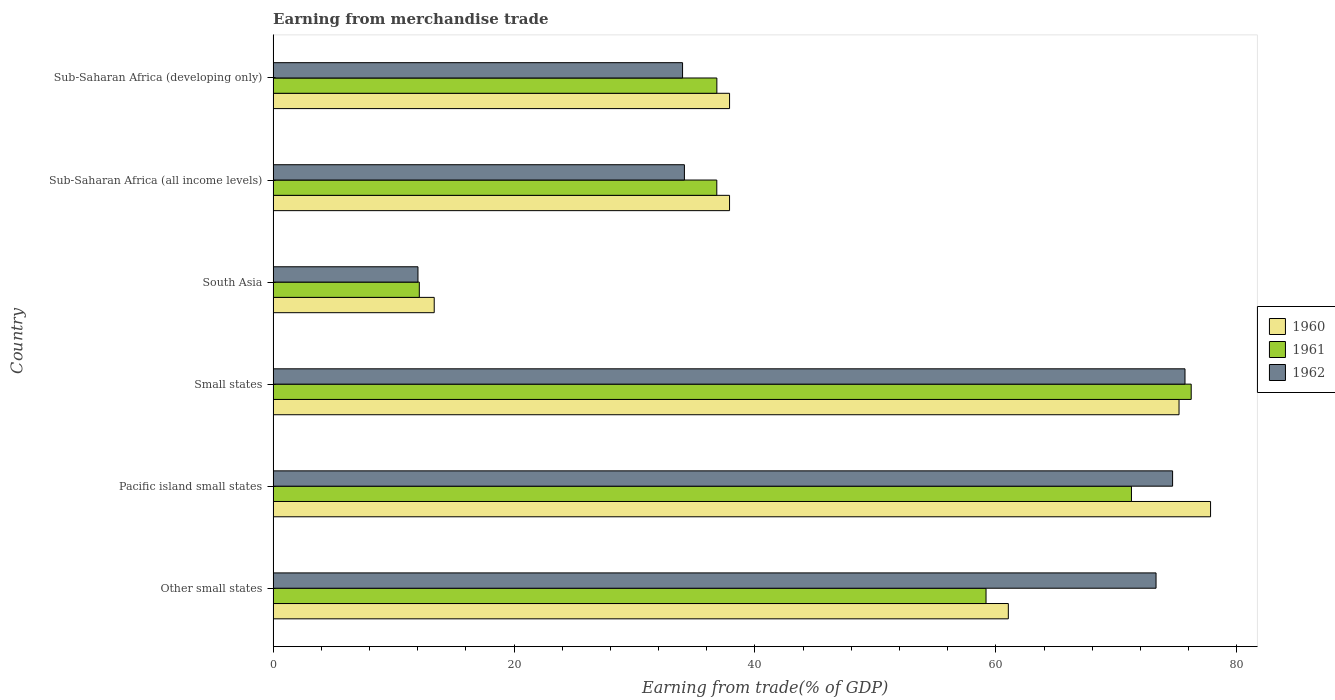How many groups of bars are there?
Offer a terse response. 6. What is the label of the 6th group of bars from the top?
Your response must be concise. Other small states. What is the earnings from trade in 1961 in South Asia?
Provide a short and direct response. 12.14. Across all countries, what is the maximum earnings from trade in 1961?
Your answer should be compact. 76.21. Across all countries, what is the minimum earnings from trade in 1962?
Offer a very short reply. 12.02. In which country was the earnings from trade in 1960 maximum?
Keep it short and to the point. Pacific island small states. What is the total earnings from trade in 1961 in the graph?
Give a very brief answer. 292.45. What is the difference between the earnings from trade in 1960 in Pacific island small states and that in Small states?
Make the answer very short. 2.62. What is the difference between the earnings from trade in 1962 in Other small states and the earnings from trade in 1960 in Small states?
Provide a short and direct response. -1.91. What is the average earnings from trade in 1960 per country?
Provide a short and direct response. 50.53. What is the difference between the earnings from trade in 1960 and earnings from trade in 1962 in Sub-Saharan Africa (developing only)?
Your response must be concise. 3.9. What is the ratio of the earnings from trade in 1961 in Small states to that in Sub-Saharan Africa (all income levels)?
Make the answer very short. 2.07. Is the difference between the earnings from trade in 1960 in Pacific island small states and Sub-Saharan Africa (all income levels) greater than the difference between the earnings from trade in 1962 in Pacific island small states and Sub-Saharan Africa (all income levels)?
Provide a succinct answer. No. What is the difference between the highest and the second highest earnings from trade in 1962?
Provide a short and direct response. 1.03. What is the difference between the highest and the lowest earnings from trade in 1962?
Provide a short and direct response. 63.67. What does the 1st bar from the top in Sub-Saharan Africa (all income levels) represents?
Your response must be concise. 1962. What does the 1st bar from the bottom in Other small states represents?
Your answer should be compact. 1960. What is the difference between two consecutive major ticks on the X-axis?
Make the answer very short. 20. Are the values on the major ticks of X-axis written in scientific E-notation?
Your answer should be very brief. No. Does the graph contain grids?
Ensure brevity in your answer.  No. What is the title of the graph?
Offer a very short reply. Earning from merchandise trade. What is the label or title of the X-axis?
Your answer should be compact. Earning from trade(% of GDP). What is the Earning from trade(% of GDP) of 1960 in Other small states?
Ensure brevity in your answer.  61.03. What is the Earning from trade(% of GDP) of 1961 in Other small states?
Your answer should be very brief. 59.18. What is the Earning from trade(% of GDP) in 1962 in Other small states?
Your answer should be very brief. 73.29. What is the Earning from trade(% of GDP) of 1960 in Pacific island small states?
Provide a short and direct response. 77.82. What is the Earning from trade(% of GDP) of 1961 in Pacific island small states?
Make the answer very short. 71.25. What is the Earning from trade(% of GDP) in 1962 in Pacific island small states?
Keep it short and to the point. 74.67. What is the Earning from trade(% of GDP) of 1960 in Small states?
Keep it short and to the point. 75.2. What is the Earning from trade(% of GDP) of 1961 in Small states?
Your answer should be compact. 76.21. What is the Earning from trade(% of GDP) in 1962 in Small states?
Make the answer very short. 75.7. What is the Earning from trade(% of GDP) of 1960 in South Asia?
Offer a terse response. 13.37. What is the Earning from trade(% of GDP) in 1961 in South Asia?
Offer a very short reply. 12.14. What is the Earning from trade(% of GDP) of 1962 in South Asia?
Offer a terse response. 12.02. What is the Earning from trade(% of GDP) of 1960 in Sub-Saharan Africa (all income levels)?
Make the answer very short. 37.89. What is the Earning from trade(% of GDP) in 1961 in Sub-Saharan Africa (all income levels)?
Provide a succinct answer. 36.83. What is the Earning from trade(% of GDP) in 1962 in Sub-Saharan Africa (all income levels)?
Your response must be concise. 34.14. What is the Earning from trade(% of GDP) in 1960 in Sub-Saharan Africa (developing only)?
Your answer should be very brief. 37.89. What is the Earning from trade(% of GDP) of 1961 in Sub-Saharan Africa (developing only)?
Your answer should be very brief. 36.84. What is the Earning from trade(% of GDP) of 1962 in Sub-Saharan Africa (developing only)?
Offer a very short reply. 33.99. Across all countries, what is the maximum Earning from trade(% of GDP) of 1960?
Give a very brief answer. 77.82. Across all countries, what is the maximum Earning from trade(% of GDP) in 1961?
Provide a succinct answer. 76.21. Across all countries, what is the maximum Earning from trade(% of GDP) of 1962?
Ensure brevity in your answer.  75.7. Across all countries, what is the minimum Earning from trade(% of GDP) in 1960?
Offer a terse response. 13.37. Across all countries, what is the minimum Earning from trade(% of GDP) of 1961?
Your response must be concise. 12.14. Across all countries, what is the minimum Earning from trade(% of GDP) of 1962?
Give a very brief answer. 12.02. What is the total Earning from trade(% of GDP) of 1960 in the graph?
Ensure brevity in your answer.  303.21. What is the total Earning from trade(% of GDP) in 1961 in the graph?
Provide a short and direct response. 292.45. What is the total Earning from trade(% of GDP) of 1962 in the graph?
Offer a terse response. 303.81. What is the difference between the Earning from trade(% of GDP) of 1960 in Other small states and that in Pacific island small states?
Offer a very short reply. -16.79. What is the difference between the Earning from trade(% of GDP) of 1961 in Other small states and that in Pacific island small states?
Your answer should be compact. -12.07. What is the difference between the Earning from trade(% of GDP) of 1962 in Other small states and that in Pacific island small states?
Offer a terse response. -1.37. What is the difference between the Earning from trade(% of GDP) in 1960 in Other small states and that in Small states?
Your response must be concise. -14.17. What is the difference between the Earning from trade(% of GDP) in 1961 in Other small states and that in Small states?
Offer a terse response. -17.03. What is the difference between the Earning from trade(% of GDP) in 1962 in Other small states and that in Small states?
Your answer should be compact. -2.4. What is the difference between the Earning from trade(% of GDP) of 1960 in Other small states and that in South Asia?
Ensure brevity in your answer.  47.66. What is the difference between the Earning from trade(% of GDP) of 1961 in Other small states and that in South Asia?
Offer a very short reply. 47.05. What is the difference between the Earning from trade(% of GDP) in 1962 in Other small states and that in South Asia?
Provide a succinct answer. 61.27. What is the difference between the Earning from trade(% of GDP) in 1960 in Other small states and that in Sub-Saharan Africa (all income levels)?
Your answer should be very brief. 23.14. What is the difference between the Earning from trade(% of GDP) of 1961 in Other small states and that in Sub-Saharan Africa (all income levels)?
Keep it short and to the point. 22.35. What is the difference between the Earning from trade(% of GDP) of 1962 in Other small states and that in Sub-Saharan Africa (all income levels)?
Give a very brief answer. 39.15. What is the difference between the Earning from trade(% of GDP) in 1960 in Other small states and that in Sub-Saharan Africa (developing only)?
Ensure brevity in your answer.  23.14. What is the difference between the Earning from trade(% of GDP) of 1961 in Other small states and that in Sub-Saharan Africa (developing only)?
Keep it short and to the point. 22.35. What is the difference between the Earning from trade(% of GDP) in 1962 in Other small states and that in Sub-Saharan Africa (developing only)?
Provide a short and direct response. 39.3. What is the difference between the Earning from trade(% of GDP) in 1960 in Pacific island small states and that in Small states?
Your answer should be compact. 2.62. What is the difference between the Earning from trade(% of GDP) in 1961 in Pacific island small states and that in Small states?
Your answer should be very brief. -4.96. What is the difference between the Earning from trade(% of GDP) in 1962 in Pacific island small states and that in Small states?
Keep it short and to the point. -1.03. What is the difference between the Earning from trade(% of GDP) of 1960 in Pacific island small states and that in South Asia?
Provide a short and direct response. 64.45. What is the difference between the Earning from trade(% of GDP) in 1961 in Pacific island small states and that in South Asia?
Give a very brief answer. 59.12. What is the difference between the Earning from trade(% of GDP) of 1962 in Pacific island small states and that in South Asia?
Your response must be concise. 62.64. What is the difference between the Earning from trade(% of GDP) of 1960 in Pacific island small states and that in Sub-Saharan Africa (all income levels)?
Give a very brief answer. 39.93. What is the difference between the Earning from trade(% of GDP) of 1961 in Pacific island small states and that in Sub-Saharan Africa (all income levels)?
Provide a succinct answer. 34.42. What is the difference between the Earning from trade(% of GDP) in 1962 in Pacific island small states and that in Sub-Saharan Africa (all income levels)?
Offer a terse response. 40.53. What is the difference between the Earning from trade(% of GDP) in 1960 in Pacific island small states and that in Sub-Saharan Africa (developing only)?
Offer a terse response. 39.93. What is the difference between the Earning from trade(% of GDP) of 1961 in Pacific island small states and that in Sub-Saharan Africa (developing only)?
Offer a terse response. 34.42. What is the difference between the Earning from trade(% of GDP) of 1962 in Pacific island small states and that in Sub-Saharan Africa (developing only)?
Provide a short and direct response. 40.68. What is the difference between the Earning from trade(% of GDP) in 1960 in Small states and that in South Asia?
Provide a succinct answer. 61.83. What is the difference between the Earning from trade(% of GDP) of 1961 in Small states and that in South Asia?
Keep it short and to the point. 64.08. What is the difference between the Earning from trade(% of GDP) in 1962 in Small states and that in South Asia?
Offer a very short reply. 63.67. What is the difference between the Earning from trade(% of GDP) of 1960 in Small states and that in Sub-Saharan Africa (all income levels)?
Keep it short and to the point. 37.31. What is the difference between the Earning from trade(% of GDP) in 1961 in Small states and that in Sub-Saharan Africa (all income levels)?
Provide a succinct answer. 39.38. What is the difference between the Earning from trade(% of GDP) of 1962 in Small states and that in Sub-Saharan Africa (all income levels)?
Give a very brief answer. 41.55. What is the difference between the Earning from trade(% of GDP) in 1960 in Small states and that in Sub-Saharan Africa (developing only)?
Give a very brief answer. 37.31. What is the difference between the Earning from trade(% of GDP) of 1961 in Small states and that in Sub-Saharan Africa (developing only)?
Provide a short and direct response. 39.38. What is the difference between the Earning from trade(% of GDP) of 1962 in Small states and that in Sub-Saharan Africa (developing only)?
Provide a short and direct response. 41.71. What is the difference between the Earning from trade(% of GDP) of 1960 in South Asia and that in Sub-Saharan Africa (all income levels)?
Your response must be concise. -24.52. What is the difference between the Earning from trade(% of GDP) of 1961 in South Asia and that in Sub-Saharan Africa (all income levels)?
Keep it short and to the point. -24.7. What is the difference between the Earning from trade(% of GDP) of 1962 in South Asia and that in Sub-Saharan Africa (all income levels)?
Offer a very short reply. -22.12. What is the difference between the Earning from trade(% of GDP) in 1960 in South Asia and that in Sub-Saharan Africa (developing only)?
Ensure brevity in your answer.  -24.52. What is the difference between the Earning from trade(% of GDP) in 1961 in South Asia and that in Sub-Saharan Africa (developing only)?
Give a very brief answer. -24.7. What is the difference between the Earning from trade(% of GDP) of 1962 in South Asia and that in Sub-Saharan Africa (developing only)?
Give a very brief answer. -21.96. What is the difference between the Earning from trade(% of GDP) of 1960 in Sub-Saharan Africa (all income levels) and that in Sub-Saharan Africa (developing only)?
Your answer should be compact. -0. What is the difference between the Earning from trade(% of GDP) of 1961 in Sub-Saharan Africa (all income levels) and that in Sub-Saharan Africa (developing only)?
Provide a short and direct response. -0. What is the difference between the Earning from trade(% of GDP) of 1962 in Sub-Saharan Africa (all income levels) and that in Sub-Saharan Africa (developing only)?
Make the answer very short. 0.15. What is the difference between the Earning from trade(% of GDP) of 1960 in Other small states and the Earning from trade(% of GDP) of 1961 in Pacific island small states?
Make the answer very short. -10.22. What is the difference between the Earning from trade(% of GDP) of 1960 in Other small states and the Earning from trade(% of GDP) of 1962 in Pacific island small states?
Offer a terse response. -13.64. What is the difference between the Earning from trade(% of GDP) in 1961 in Other small states and the Earning from trade(% of GDP) in 1962 in Pacific island small states?
Your response must be concise. -15.49. What is the difference between the Earning from trade(% of GDP) in 1960 in Other small states and the Earning from trade(% of GDP) in 1961 in Small states?
Offer a very short reply. -15.18. What is the difference between the Earning from trade(% of GDP) of 1960 in Other small states and the Earning from trade(% of GDP) of 1962 in Small states?
Provide a succinct answer. -14.67. What is the difference between the Earning from trade(% of GDP) in 1961 in Other small states and the Earning from trade(% of GDP) in 1962 in Small states?
Your response must be concise. -16.52. What is the difference between the Earning from trade(% of GDP) of 1960 in Other small states and the Earning from trade(% of GDP) of 1961 in South Asia?
Give a very brief answer. 48.9. What is the difference between the Earning from trade(% of GDP) of 1960 in Other small states and the Earning from trade(% of GDP) of 1962 in South Asia?
Keep it short and to the point. 49.01. What is the difference between the Earning from trade(% of GDP) of 1961 in Other small states and the Earning from trade(% of GDP) of 1962 in South Asia?
Ensure brevity in your answer.  47.16. What is the difference between the Earning from trade(% of GDP) of 1960 in Other small states and the Earning from trade(% of GDP) of 1961 in Sub-Saharan Africa (all income levels)?
Keep it short and to the point. 24.2. What is the difference between the Earning from trade(% of GDP) in 1960 in Other small states and the Earning from trade(% of GDP) in 1962 in Sub-Saharan Africa (all income levels)?
Ensure brevity in your answer.  26.89. What is the difference between the Earning from trade(% of GDP) of 1961 in Other small states and the Earning from trade(% of GDP) of 1962 in Sub-Saharan Africa (all income levels)?
Make the answer very short. 25.04. What is the difference between the Earning from trade(% of GDP) of 1960 in Other small states and the Earning from trade(% of GDP) of 1961 in Sub-Saharan Africa (developing only)?
Your response must be concise. 24.2. What is the difference between the Earning from trade(% of GDP) of 1960 in Other small states and the Earning from trade(% of GDP) of 1962 in Sub-Saharan Africa (developing only)?
Your answer should be very brief. 27.04. What is the difference between the Earning from trade(% of GDP) of 1961 in Other small states and the Earning from trade(% of GDP) of 1962 in Sub-Saharan Africa (developing only)?
Your answer should be compact. 25.19. What is the difference between the Earning from trade(% of GDP) in 1960 in Pacific island small states and the Earning from trade(% of GDP) in 1961 in Small states?
Keep it short and to the point. 1.61. What is the difference between the Earning from trade(% of GDP) of 1960 in Pacific island small states and the Earning from trade(% of GDP) of 1962 in Small states?
Your answer should be compact. 2.12. What is the difference between the Earning from trade(% of GDP) of 1961 in Pacific island small states and the Earning from trade(% of GDP) of 1962 in Small states?
Your answer should be compact. -4.44. What is the difference between the Earning from trade(% of GDP) of 1960 in Pacific island small states and the Earning from trade(% of GDP) of 1961 in South Asia?
Make the answer very short. 65.68. What is the difference between the Earning from trade(% of GDP) of 1960 in Pacific island small states and the Earning from trade(% of GDP) of 1962 in South Asia?
Offer a terse response. 65.8. What is the difference between the Earning from trade(% of GDP) of 1961 in Pacific island small states and the Earning from trade(% of GDP) of 1962 in South Asia?
Offer a terse response. 59.23. What is the difference between the Earning from trade(% of GDP) in 1960 in Pacific island small states and the Earning from trade(% of GDP) in 1961 in Sub-Saharan Africa (all income levels)?
Your response must be concise. 40.99. What is the difference between the Earning from trade(% of GDP) in 1960 in Pacific island small states and the Earning from trade(% of GDP) in 1962 in Sub-Saharan Africa (all income levels)?
Give a very brief answer. 43.68. What is the difference between the Earning from trade(% of GDP) of 1961 in Pacific island small states and the Earning from trade(% of GDP) of 1962 in Sub-Saharan Africa (all income levels)?
Offer a terse response. 37.11. What is the difference between the Earning from trade(% of GDP) of 1960 in Pacific island small states and the Earning from trade(% of GDP) of 1961 in Sub-Saharan Africa (developing only)?
Offer a very short reply. 40.98. What is the difference between the Earning from trade(% of GDP) of 1960 in Pacific island small states and the Earning from trade(% of GDP) of 1962 in Sub-Saharan Africa (developing only)?
Your response must be concise. 43.83. What is the difference between the Earning from trade(% of GDP) in 1961 in Pacific island small states and the Earning from trade(% of GDP) in 1962 in Sub-Saharan Africa (developing only)?
Your answer should be very brief. 37.26. What is the difference between the Earning from trade(% of GDP) of 1960 in Small states and the Earning from trade(% of GDP) of 1961 in South Asia?
Ensure brevity in your answer.  63.07. What is the difference between the Earning from trade(% of GDP) in 1960 in Small states and the Earning from trade(% of GDP) in 1962 in South Asia?
Your answer should be compact. 63.18. What is the difference between the Earning from trade(% of GDP) in 1961 in Small states and the Earning from trade(% of GDP) in 1962 in South Asia?
Your answer should be very brief. 64.19. What is the difference between the Earning from trade(% of GDP) of 1960 in Small states and the Earning from trade(% of GDP) of 1961 in Sub-Saharan Africa (all income levels)?
Give a very brief answer. 38.37. What is the difference between the Earning from trade(% of GDP) of 1960 in Small states and the Earning from trade(% of GDP) of 1962 in Sub-Saharan Africa (all income levels)?
Provide a short and direct response. 41.06. What is the difference between the Earning from trade(% of GDP) in 1961 in Small states and the Earning from trade(% of GDP) in 1962 in Sub-Saharan Africa (all income levels)?
Provide a succinct answer. 42.07. What is the difference between the Earning from trade(% of GDP) of 1960 in Small states and the Earning from trade(% of GDP) of 1961 in Sub-Saharan Africa (developing only)?
Give a very brief answer. 38.37. What is the difference between the Earning from trade(% of GDP) of 1960 in Small states and the Earning from trade(% of GDP) of 1962 in Sub-Saharan Africa (developing only)?
Ensure brevity in your answer.  41.21. What is the difference between the Earning from trade(% of GDP) of 1961 in Small states and the Earning from trade(% of GDP) of 1962 in Sub-Saharan Africa (developing only)?
Keep it short and to the point. 42.22. What is the difference between the Earning from trade(% of GDP) in 1960 in South Asia and the Earning from trade(% of GDP) in 1961 in Sub-Saharan Africa (all income levels)?
Offer a very short reply. -23.46. What is the difference between the Earning from trade(% of GDP) in 1960 in South Asia and the Earning from trade(% of GDP) in 1962 in Sub-Saharan Africa (all income levels)?
Provide a short and direct response. -20.77. What is the difference between the Earning from trade(% of GDP) in 1961 in South Asia and the Earning from trade(% of GDP) in 1962 in Sub-Saharan Africa (all income levels)?
Offer a terse response. -22.01. What is the difference between the Earning from trade(% of GDP) of 1960 in South Asia and the Earning from trade(% of GDP) of 1961 in Sub-Saharan Africa (developing only)?
Keep it short and to the point. -23.46. What is the difference between the Earning from trade(% of GDP) of 1960 in South Asia and the Earning from trade(% of GDP) of 1962 in Sub-Saharan Africa (developing only)?
Your response must be concise. -20.62. What is the difference between the Earning from trade(% of GDP) of 1961 in South Asia and the Earning from trade(% of GDP) of 1962 in Sub-Saharan Africa (developing only)?
Your answer should be very brief. -21.85. What is the difference between the Earning from trade(% of GDP) of 1960 in Sub-Saharan Africa (all income levels) and the Earning from trade(% of GDP) of 1961 in Sub-Saharan Africa (developing only)?
Your response must be concise. 1.05. What is the difference between the Earning from trade(% of GDP) in 1960 in Sub-Saharan Africa (all income levels) and the Earning from trade(% of GDP) in 1962 in Sub-Saharan Africa (developing only)?
Make the answer very short. 3.9. What is the difference between the Earning from trade(% of GDP) of 1961 in Sub-Saharan Africa (all income levels) and the Earning from trade(% of GDP) of 1962 in Sub-Saharan Africa (developing only)?
Offer a very short reply. 2.84. What is the average Earning from trade(% of GDP) of 1960 per country?
Keep it short and to the point. 50.53. What is the average Earning from trade(% of GDP) of 1961 per country?
Your response must be concise. 48.74. What is the average Earning from trade(% of GDP) in 1962 per country?
Offer a very short reply. 50.64. What is the difference between the Earning from trade(% of GDP) of 1960 and Earning from trade(% of GDP) of 1961 in Other small states?
Give a very brief answer. 1.85. What is the difference between the Earning from trade(% of GDP) in 1960 and Earning from trade(% of GDP) in 1962 in Other small states?
Ensure brevity in your answer.  -12.26. What is the difference between the Earning from trade(% of GDP) in 1961 and Earning from trade(% of GDP) in 1962 in Other small states?
Ensure brevity in your answer.  -14.11. What is the difference between the Earning from trade(% of GDP) in 1960 and Earning from trade(% of GDP) in 1961 in Pacific island small states?
Make the answer very short. 6.57. What is the difference between the Earning from trade(% of GDP) of 1960 and Earning from trade(% of GDP) of 1962 in Pacific island small states?
Keep it short and to the point. 3.15. What is the difference between the Earning from trade(% of GDP) in 1961 and Earning from trade(% of GDP) in 1962 in Pacific island small states?
Ensure brevity in your answer.  -3.42. What is the difference between the Earning from trade(% of GDP) of 1960 and Earning from trade(% of GDP) of 1961 in Small states?
Ensure brevity in your answer.  -1.01. What is the difference between the Earning from trade(% of GDP) in 1960 and Earning from trade(% of GDP) in 1962 in Small states?
Provide a short and direct response. -0.5. What is the difference between the Earning from trade(% of GDP) in 1961 and Earning from trade(% of GDP) in 1962 in Small states?
Provide a short and direct response. 0.52. What is the difference between the Earning from trade(% of GDP) in 1960 and Earning from trade(% of GDP) in 1961 in South Asia?
Your answer should be very brief. 1.24. What is the difference between the Earning from trade(% of GDP) in 1960 and Earning from trade(% of GDP) in 1962 in South Asia?
Ensure brevity in your answer.  1.35. What is the difference between the Earning from trade(% of GDP) in 1961 and Earning from trade(% of GDP) in 1962 in South Asia?
Offer a terse response. 0.11. What is the difference between the Earning from trade(% of GDP) of 1960 and Earning from trade(% of GDP) of 1961 in Sub-Saharan Africa (all income levels)?
Your answer should be compact. 1.06. What is the difference between the Earning from trade(% of GDP) of 1960 and Earning from trade(% of GDP) of 1962 in Sub-Saharan Africa (all income levels)?
Provide a short and direct response. 3.75. What is the difference between the Earning from trade(% of GDP) in 1961 and Earning from trade(% of GDP) in 1962 in Sub-Saharan Africa (all income levels)?
Ensure brevity in your answer.  2.69. What is the difference between the Earning from trade(% of GDP) in 1960 and Earning from trade(% of GDP) in 1961 in Sub-Saharan Africa (developing only)?
Your answer should be compact. 1.06. What is the difference between the Earning from trade(% of GDP) of 1960 and Earning from trade(% of GDP) of 1962 in Sub-Saharan Africa (developing only)?
Your answer should be very brief. 3.9. What is the difference between the Earning from trade(% of GDP) in 1961 and Earning from trade(% of GDP) in 1962 in Sub-Saharan Africa (developing only)?
Give a very brief answer. 2.85. What is the ratio of the Earning from trade(% of GDP) in 1960 in Other small states to that in Pacific island small states?
Keep it short and to the point. 0.78. What is the ratio of the Earning from trade(% of GDP) of 1961 in Other small states to that in Pacific island small states?
Your answer should be very brief. 0.83. What is the ratio of the Earning from trade(% of GDP) of 1962 in Other small states to that in Pacific island small states?
Your answer should be compact. 0.98. What is the ratio of the Earning from trade(% of GDP) in 1960 in Other small states to that in Small states?
Ensure brevity in your answer.  0.81. What is the ratio of the Earning from trade(% of GDP) of 1961 in Other small states to that in Small states?
Your response must be concise. 0.78. What is the ratio of the Earning from trade(% of GDP) in 1962 in Other small states to that in Small states?
Offer a terse response. 0.97. What is the ratio of the Earning from trade(% of GDP) of 1960 in Other small states to that in South Asia?
Your answer should be very brief. 4.56. What is the ratio of the Earning from trade(% of GDP) in 1961 in Other small states to that in South Asia?
Your answer should be compact. 4.88. What is the ratio of the Earning from trade(% of GDP) of 1962 in Other small states to that in South Asia?
Give a very brief answer. 6.1. What is the ratio of the Earning from trade(% of GDP) in 1960 in Other small states to that in Sub-Saharan Africa (all income levels)?
Your answer should be compact. 1.61. What is the ratio of the Earning from trade(% of GDP) in 1961 in Other small states to that in Sub-Saharan Africa (all income levels)?
Ensure brevity in your answer.  1.61. What is the ratio of the Earning from trade(% of GDP) of 1962 in Other small states to that in Sub-Saharan Africa (all income levels)?
Your answer should be very brief. 2.15. What is the ratio of the Earning from trade(% of GDP) in 1960 in Other small states to that in Sub-Saharan Africa (developing only)?
Ensure brevity in your answer.  1.61. What is the ratio of the Earning from trade(% of GDP) in 1961 in Other small states to that in Sub-Saharan Africa (developing only)?
Make the answer very short. 1.61. What is the ratio of the Earning from trade(% of GDP) in 1962 in Other small states to that in Sub-Saharan Africa (developing only)?
Keep it short and to the point. 2.16. What is the ratio of the Earning from trade(% of GDP) of 1960 in Pacific island small states to that in Small states?
Provide a succinct answer. 1.03. What is the ratio of the Earning from trade(% of GDP) of 1961 in Pacific island small states to that in Small states?
Ensure brevity in your answer.  0.93. What is the ratio of the Earning from trade(% of GDP) in 1962 in Pacific island small states to that in Small states?
Ensure brevity in your answer.  0.99. What is the ratio of the Earning from trade(% of GDP) of 1960 in Pacific island small states to that in South Asia?
Your answer should be compact. 5.82. What is the ratio of the Earning from trade(% of GDP) of 1961 in Pacific island small states to that in South Asia?
Make the answer very short. 5.87. What is the ratio of the Earning from trade(% of GDP) in 1962 in Pacific island small states to that in South Asia?
Provide a short and direct response. 6.21. What is the ratio of the Earning from trade(% of GDP) of 1960 in Pacific island small states to that in Sub-Saharan Africa (all income levels)?
Your answer should be very brief. 2.05. What is the ratio of the Earning from trade(% of GDP) of 1961 in Pacific island small states to that in Sub-Saharan Africa (all income levels)?
Keep it short and to the point. 1.93. What is the ratio of the Earning from trade(% of GDP) of 1962 in Pacific island small states to that in Sub-Saharan Africa (all income levels)?
Ensure brevity in your answer.  2.19. What is the ratio of the Earning from trade(% of GDP) of 1960 in Pacific island small states to that in Sub-Saharan Africa (developing only)?
Provide a short and direct response. 2.05. What is the ratio of the Earning from trade(% of GDP) in 1961 in Pacific island small states to that in Sub-Saharan Africa (developing only)?
Ensure brevity in your answer.  1.93. What is the ratio of the Earning from trade(% of GDP) in 1962 in Pacific island small states to that in Sub-Saharan Africa (developing only)?
Provide a succinct answer. 2.2. What is the ratio of the Earning from trade(% of GDP) in 1960 in Small states to that in South Asia?
Make the answer very short. 5.62. What is the ratio of the Earning from trade(% of GDP) of 1961 in Small states to that in South Asia?
Give a very brief answer. 6.28. What is the ratio of the Earning from trade(% of GDP) in 1962 in Small states to that in South Asia?
Ensure brevity in your answer.  6.3. What is the ratio of the Earning from trade(% of GDP) in 1960 in Small states to that in Sub-Saharan Africa (all income levels)?
Your answer should be compact. 1.98. What is the ratio of the Earning from trade(% of GDP) in 1961 in Small states to that in Sub-Saharan Africa (all income levels)?
Make the answer very short. 2.07. What is the ratio of the Earning from trade(% of GDP) in 1962 in Small states to that in Sub-Saharan Africa (all income levels)?
Make the answer very short. 2.22. What is the ratio of the Earning from trade(% of GDP) of 1960 in Small states to that in Sub-Saharan Africa (developing only)?
Keep it short and to the point. 1.98. What is the ratio of the Earning from trade(% of GDP) in 1961 in Small states to that in Sub-Saharan Africa (developing only)?
Your answer should be very brief. 2.07. What is the ratio of the Earning from trade(% of GDP) of 1962 in Small states to that in Sub-Saharan Africa (developing only)?
Your response must be concise. 2.23. What is the ratio of the Earning from trade(% of GDP) of 1960 in South Asia to that in Sub-Saharan Africa (all income levels)?
Your response must be concise. 0.35. What is the ratio of the Earning from trade(% of GDP) of 1961 in South Asia to that in Sub-Saharan Africa (all income levels)?
Your answer should be compact. 0.33. What is the ratio of the Earning from trade(% of GDP) of 1962 in South Asia to that in Sub-Saharan Africa (all income levels)?
Make the answer very short. 0.35. What is the ratio of the Earning from trade(% of GDP) of 1960 in South Asia to that in Sub-Saharan Africa (developing only)?
Give a very brief answer. 0.35. What is the ratio of the Earning from trade(% of GDP) in 1961 in South Asia to that in Sub-Saharan Africa (developing only)?
Keep it short and to the point. 0.33. What is the ratio of the Earning from trade(% of GDP) in 1962 in South Asia to that in Sub-Saharan Africa (developing only)?
Give a very brief answer. 0.35. What is the ratio of the Earning from trade(% of GDP) of 1962 in Sub-Saharan Africa (all income levels) to that in Sub-Saharan Africa (developing only)?
Offer a terse response. 1. What is the difference between the highest and the second highest Earning from trade(% of GDP) of 1960?
Offer a terse response. 2.62. What is the difference between the highest and the second highest Earning from trade(% of GDP) in 1961?
Ensure brevity in your answer.  4.96. What is the difference between the highest and the second highest Earning from trade(% of GDP) of 1962?
Your answer should be compact. 1.03. What is the difference between the highest and the lowest Earning from trade(% of GDP) in 1960?
Offer a terse response. 64.45. What is the difference between the highest and the lowest Earning from trade(% of GDP) in 1961?
Ensure brevity in your answer.  64.08. What is the difference between the highest and the lowest Earning from trade(% of GDP) in 1962?
Ensure brevity in your answer.  63.67. 